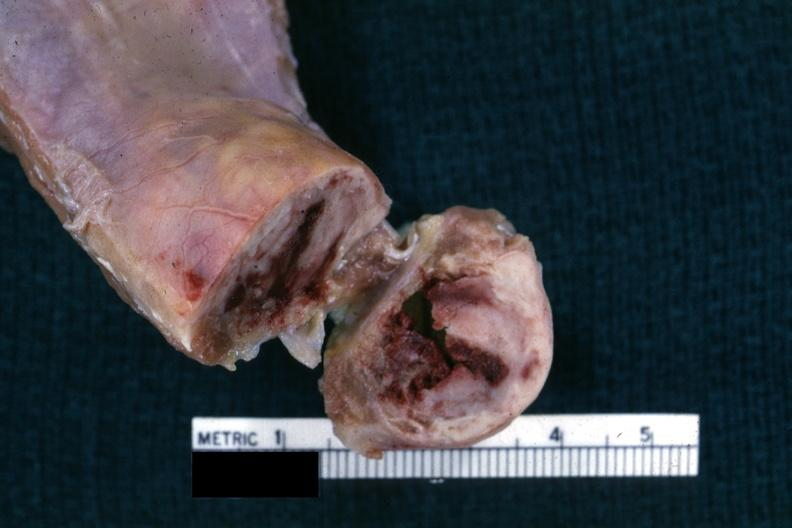what does this image show?
Answer the question using a single word or phrase. Close-up view of cross sectioned rib lesion showing white neoplastic lesion with hemorrhagic center 